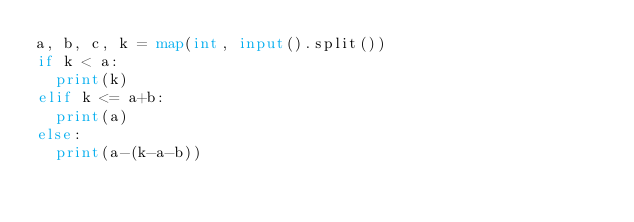<code> <loc_0><loc_0><loc_500><loc_500><_Python_>a, b, c, k = map(int, input().split())
if k < a:
  print(k)
elif k <= a+b:
  print(a)
else:
  print(a-(k-a-b))</code> 